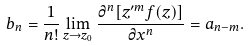Convert formula to latex. <formula><loc_0><loc_0><loc_500><loc_500>b _ { n } = \frac { 1 } { n ! } \lim _ { z \rightarrow z _ { 0 } } \frac { \partial ^ { n } [ z ^ { \prime m } f ( z ) ] } { \partial x ^ { n } } = a _ { n - m } .</formula> 